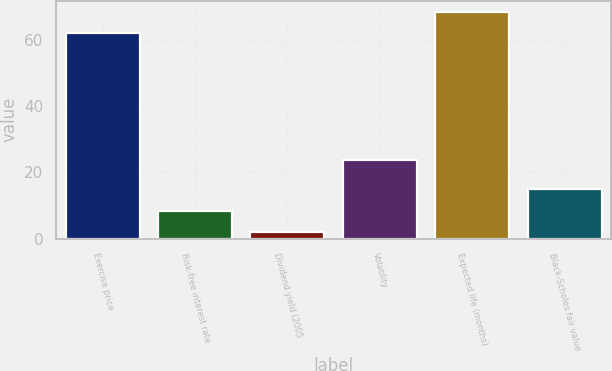<chart> <loc_0><loc_0><loc_500><loc_500><bar_chart><fcel>Exercise price<fcel>Risk-free interest rate<fcel>Dividend yield (2005<fcel>Volatility<fcel>Expected life (months)<fcel>Black-Scholes fair value<nl><fcel>61.91<fcel>8.49<fcel>2.1<fcel>23.8<fcel>68.3<fcel>14.88<nl></chart> 